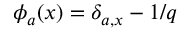<formula> <loc_0><loc_0><loc_500><loc_500>\phi _ { a } ( x ) = \delta _ { a , x } - 1 / q</formula> 